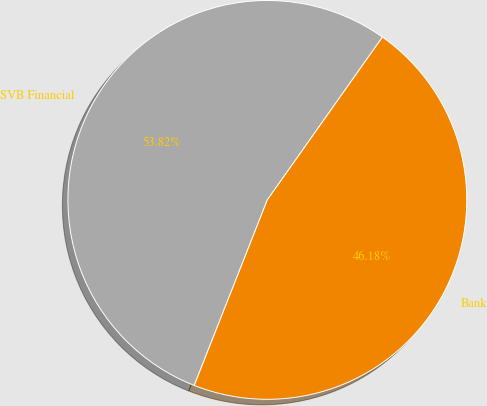Convert chart to OTSL. <chart><loc_0><loc_0><loc_500><loc_500><pie_chart><fcel>SVB Financial<fcel>Bank<nl><fcel>53.82%<fcel>46.18%<nl></chart> 